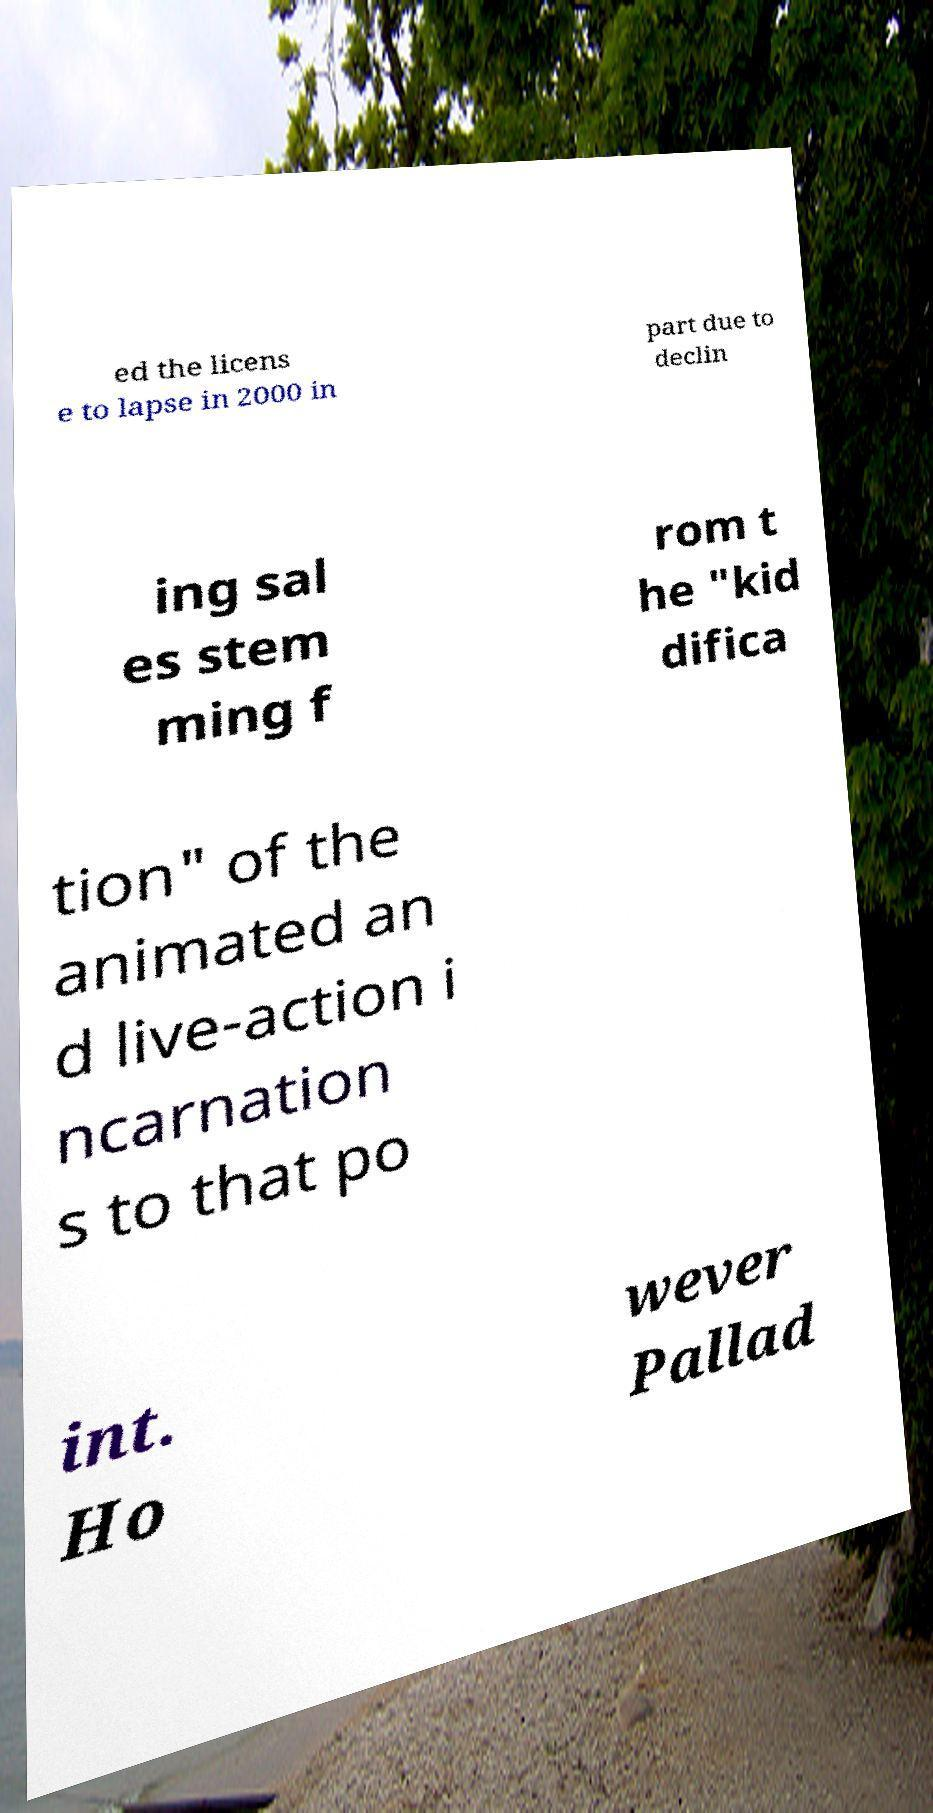For documentation purposes, I need the text within this image transcribed. Could you provide that? ed the licens e to lapse in 2000 in part due to declin ing sal es stem ming f rom t he "kid difica tion" of the animated an d live-action i ncarnation s to that po int. Ho wever Pallad 